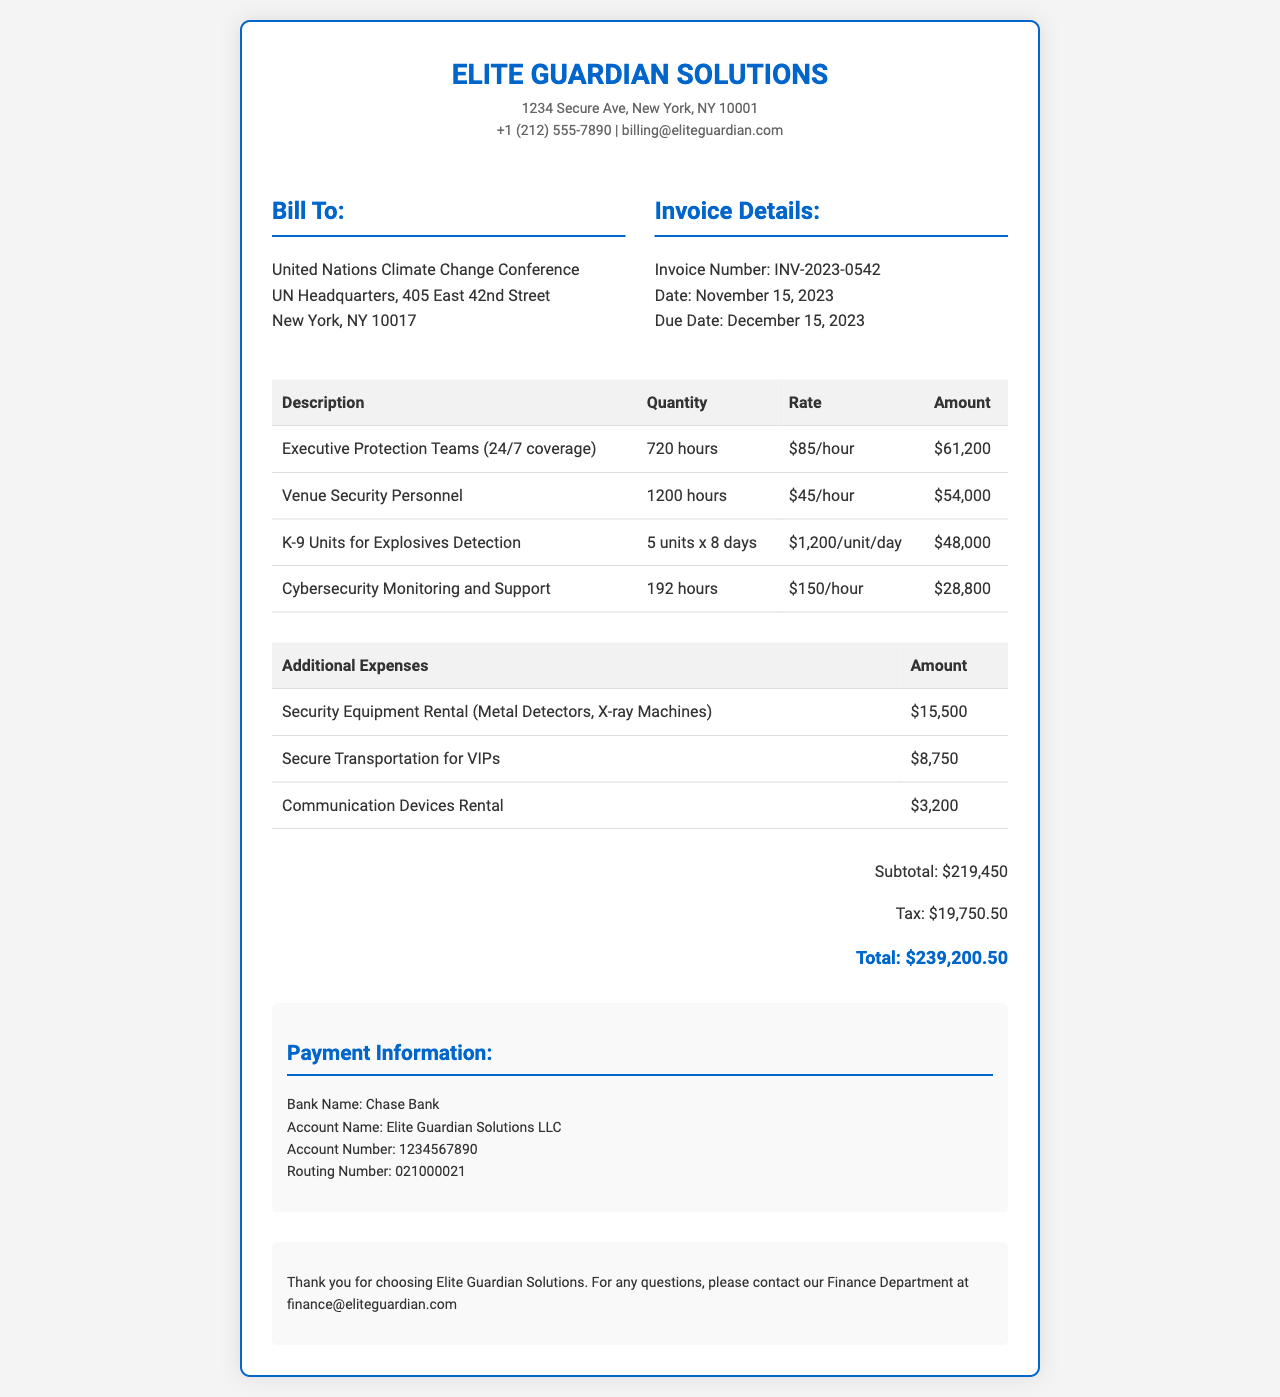What is the invoice number? The invoice number is explicitly stated in the document under the invoice details section.
Answer: INV-2023-0542 What is the total amount due? The total amount due is found in the totals section of the invoice, which combines all charges.
Answer: $239,200.50 How many hours were billed for Executive Protection Teams? The document provides a specific quantity of hours for the Executive Protection Teams in the itemized table.
Answer: 720 hours What is the rate per hour for Cybersecurity Monitoring? The rate charged for Cybersecurity Monitoring is listed in the itemized expenses table of the document.
Answer: $150/hour What is the due date for payment? The due date is mentioned in the invoice details section of the document.
Answer: December 15, 2023 How much was spent on K-9 Units for Explosives Detection? The total amount for the K-9 Units is detailed in the itemized expenses section of the invoice.
Answer: $48,000 What is the subtotal before tax? The subtotal amount before tax is provided in the totals section of the document.
Answer: $219,450 What is the amount for Secure Transportation for VIPs? The amount for Secure Transportation for VIPs is listed under additional expenses in the document.
Answer: $8,750 Who is the client billed for these services? The client information is presented prominently in the document, indicating who is being billed.
Answer: United Nations Climate Change Conference 